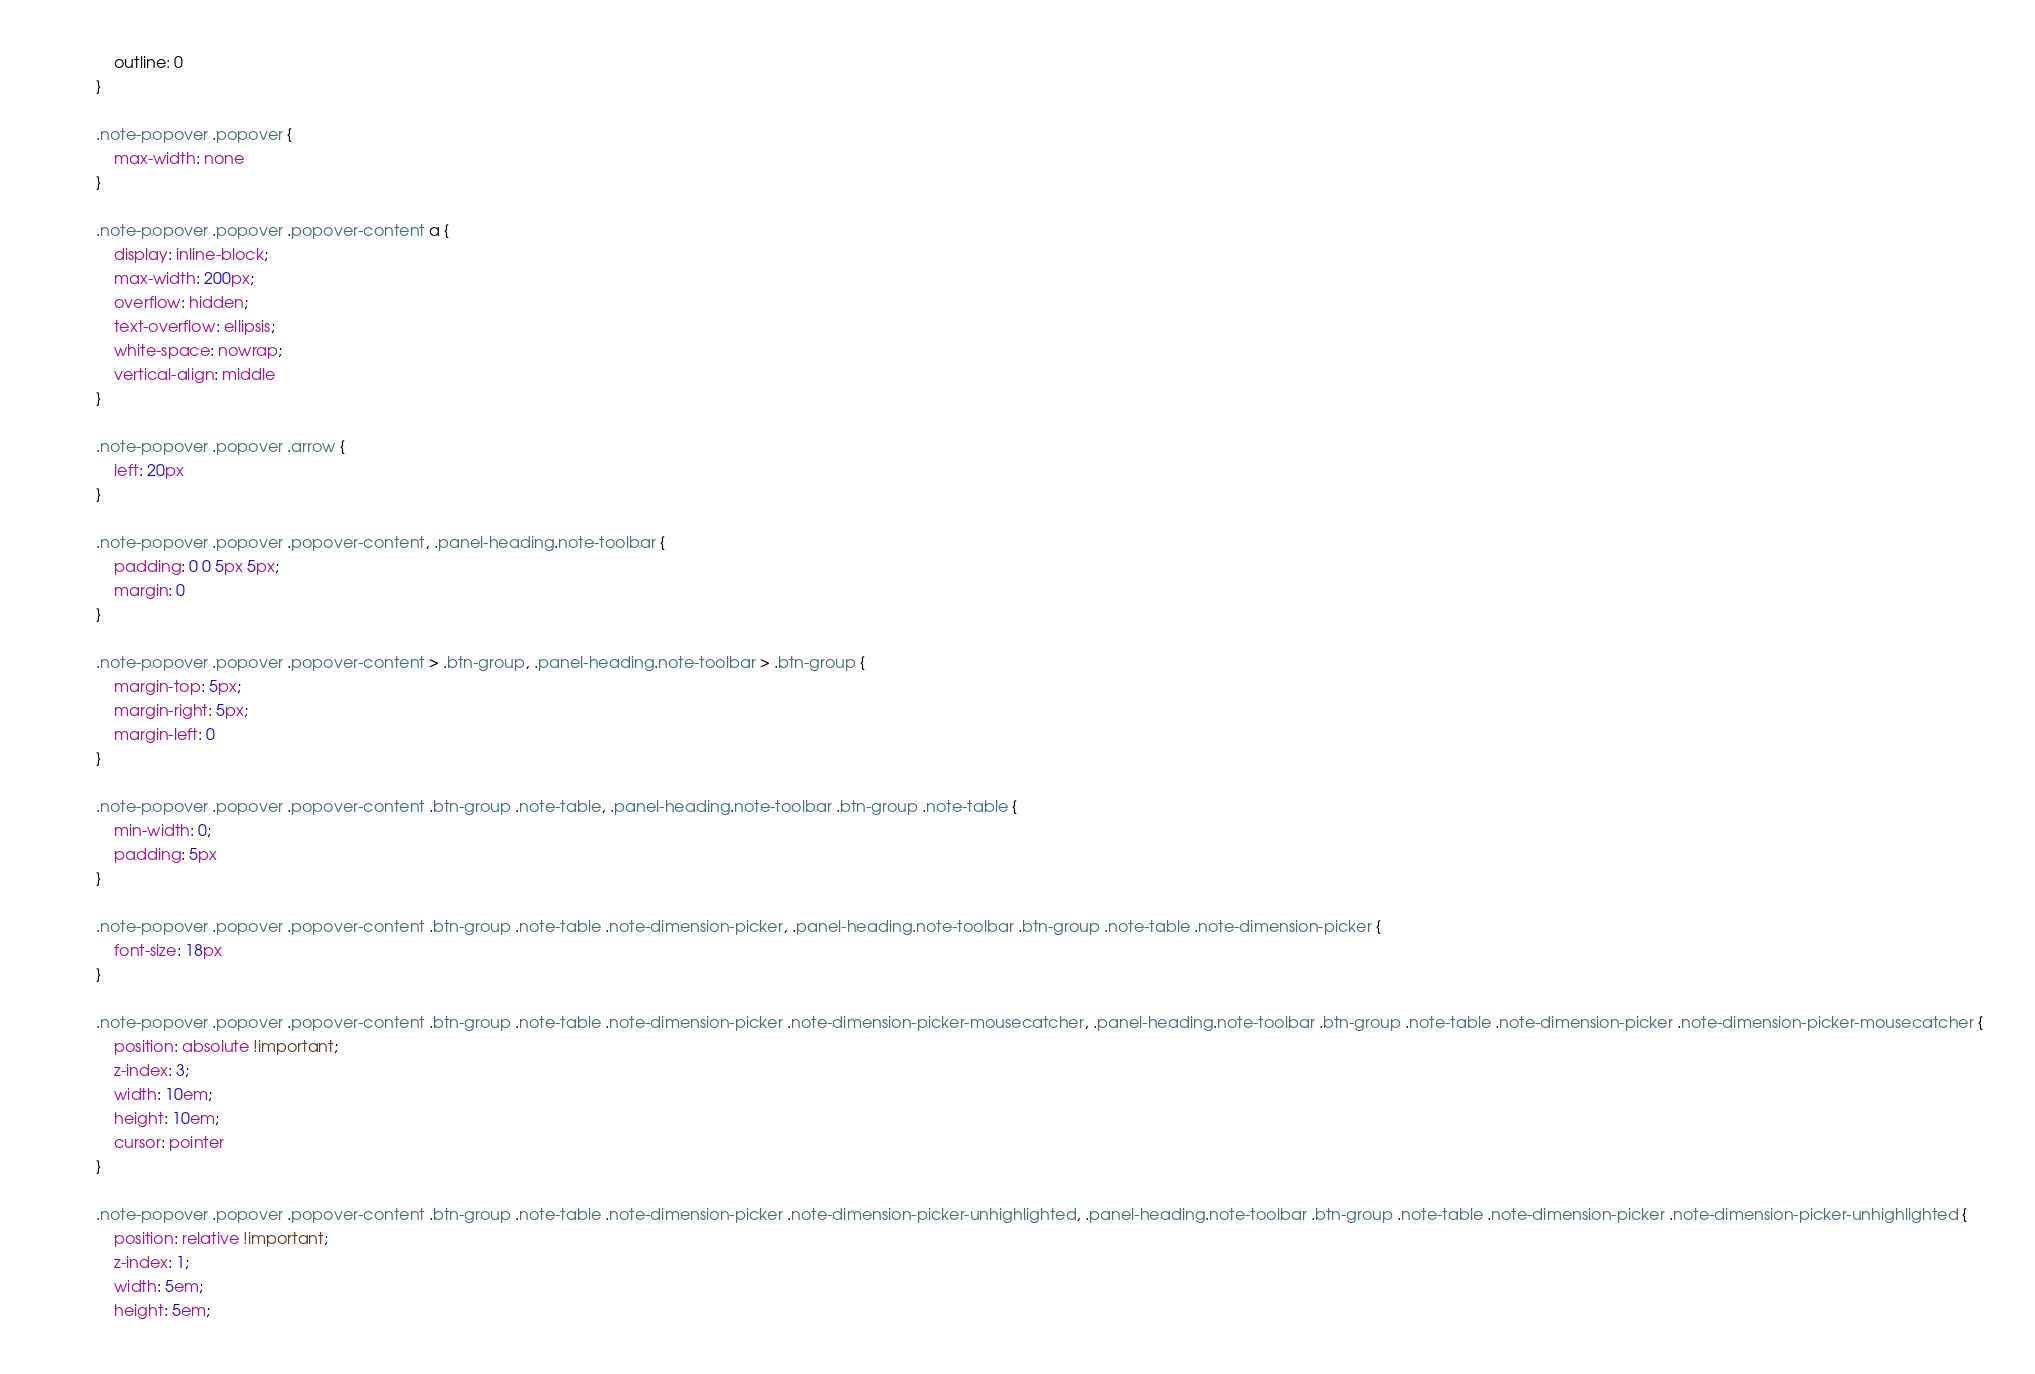Convert code to text. <code><loc_0><loc_0><loc_500><loc_500><_CSS_>    outline: 0
}

.note-popover .popover {
    max-width: none
}

.note-popover .popover .popover-content a {
    display: inline-block;
    max-width: 200px;
    overflow: hidden;
    text-overflow: ellipsis;
    white-space: nowrap;
    vertical-align: middle
}

.note-popover .popover .arrow {
    left: 20px
}

.note-popover .popover .popover-content, .panel-heading.note-toolbar {
    padding: 0 0 5px 5px;
    margin: 0
}

.note-popover .popover .popover-content > .btn-group, .panel-heading.note-toolbar > .btn-group {
    margin-top: 5px;
    margin-right: 5px;
    margin-left: 0
}

.note-popover .popover .popover-content .btn-group .note-table, .panel-heading.note-toolbar .btn-group .note-table {
    min-width: 0;
    padding: 5px
}

.note-popover .popover .popover-content .btn-group .note-table .note-dimension-picker, .panel-heading.note-toolbar .btn-group .note-table .note-dimension-picker {
    font-size: 18px
}

.note-popover .popover .popover-content .btn-group .note-table .note-dimension-picker .note-dimension-picker-mousecatcher, .panel-heading.note-toolbar .btn-group .note-table .note-dimension-picker .note-dimension-picker-mousecatcher {
    position: absolute !important;
    z-index: 3;
    width: 10em;
    height: 10em;
    cursor: pointer
}

.note-popover .popover .popover-content .btn-group .note-table .note-dimension-picker .note-dimension-picker-unhighlighted, .panel-heading.note-toolbar .btn-group .note-table .note-dimension-picker .note-dimension-picker-unhighlighted {
    position: relative !important;
    z-index: 1;
    width: 5em;
    height: 5em;</code> 